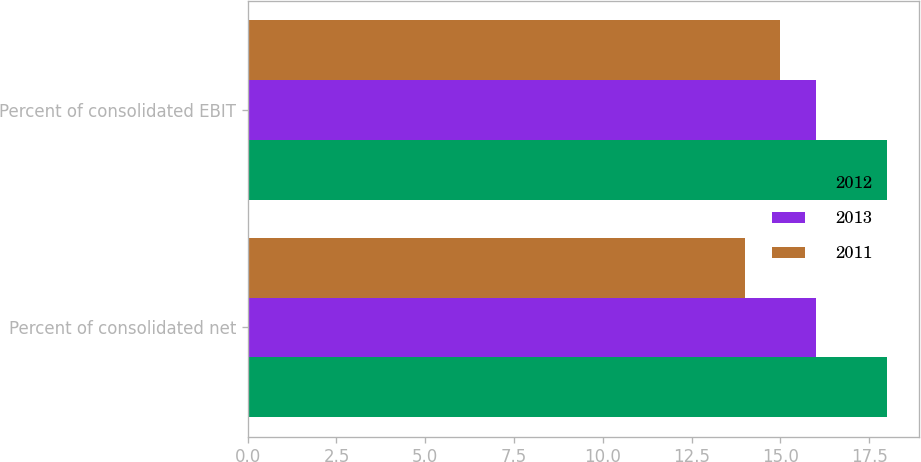Convert chart to OTSL. <chart><loc_0><loc_0><loc_500><loc_500><stacked_bar_chart><ecel><fcel>Percent of consolidated net<fcel>Percent of consolidated EBIT<nl><fcel>2012<fcel>18<fcel>18<nl><fcel>2013<fcel>16<fcel>16<nl><fcel>2011<fcel>14<fcel>15<nl></chart> 